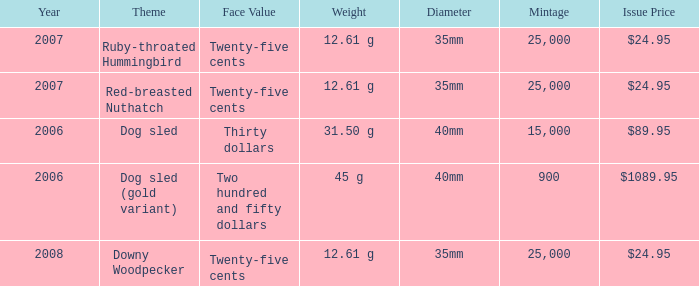What is the Year of the Coin with an Issue Price of $1089.95 and Mintage less than 900? None. 